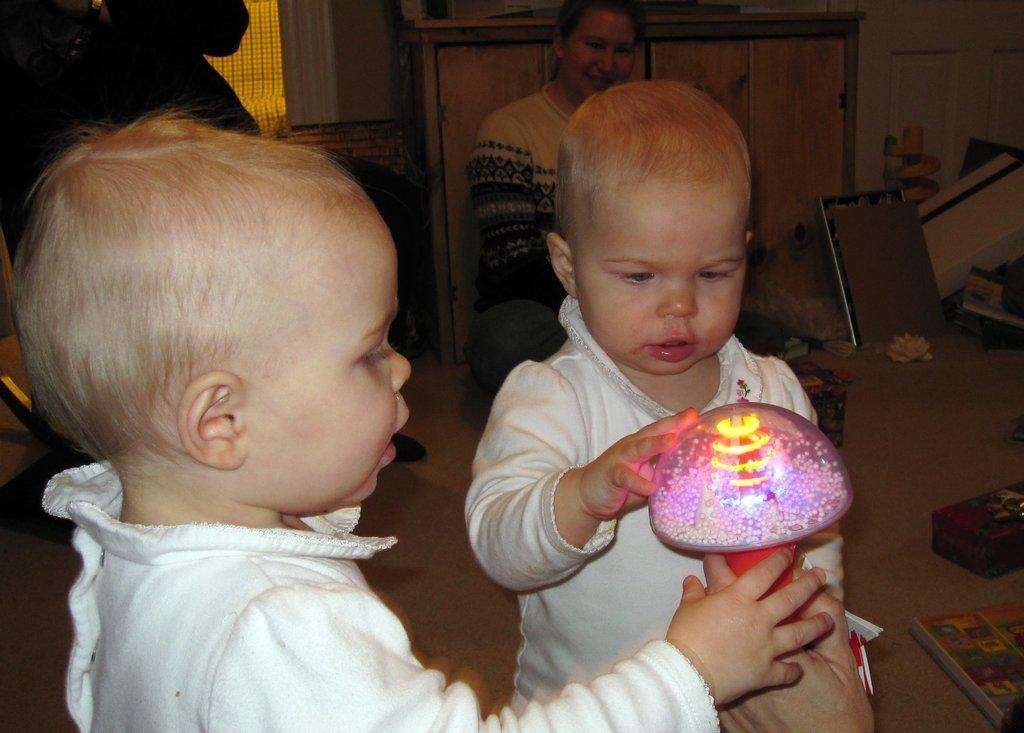Describe this image in one or two sentences. In front of the picture, we see two girls in white frocks are playing with some object. Behind them, we see a woman in white T-shirt is sitting and she is smiling. Beside her, we see some things are placed on the floor. On the right side, we see a white wall. In the left top of the picture, we see a person is standing. Behind him, we see a curtain and a pillar in white color. 